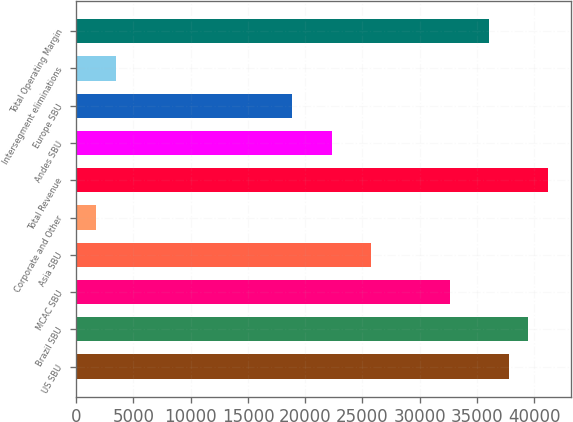<chart> <loc_0><loc_0><loc_500><loc_500><bar_chart><fcel>US SBU<fcel>Brazil SBU<fcel>MCAC SBU<fcel>Asia SBU<fcel>Corporate and Other<fcel>Total Revenue<fcel>Andes SBU<fcel>Europe SBU<fcel>Intersegment eliminations<fcel>Total Operating Margin<nl><fcel>37760.7<fcel>39477.1<fcel>32611.5<fcel>25745.9<fcel>1716.47<fcel>41193.4<fcel>22313.2<fcel>18880.4<fcel>3432.86<fcel>36044.3<nl></chart> 